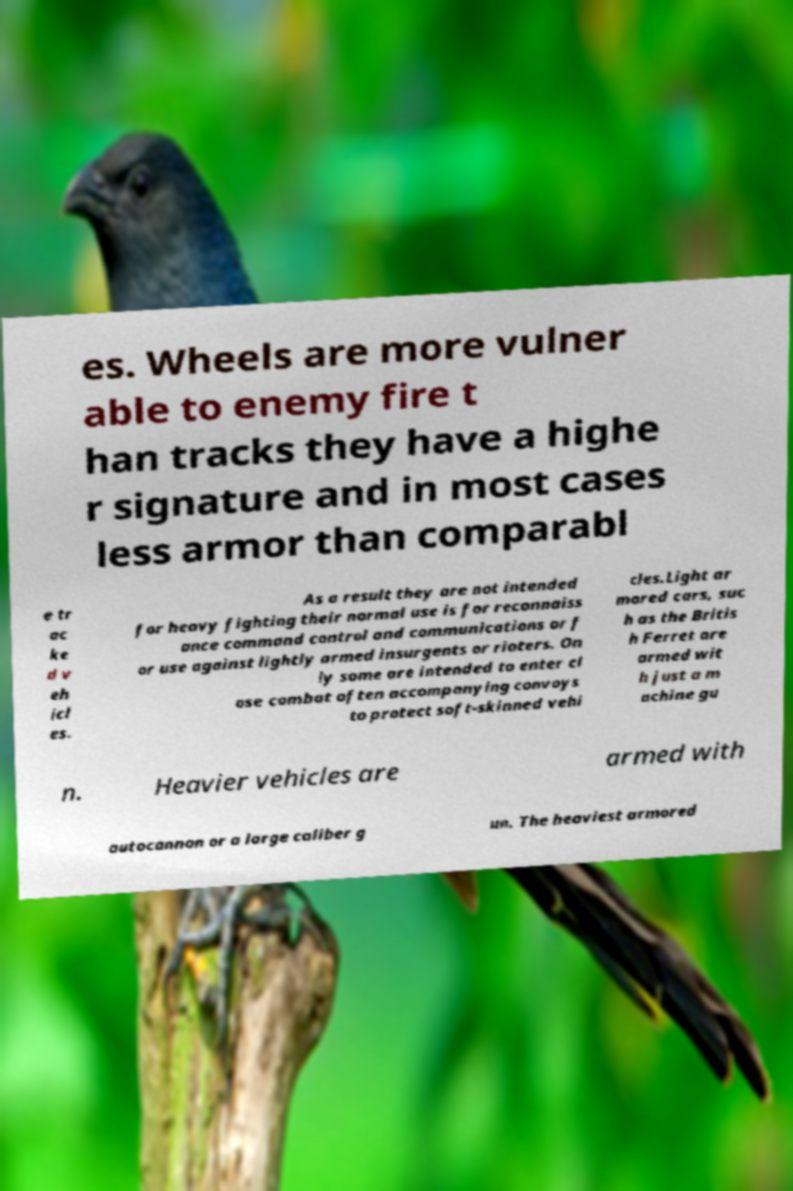For documentation purposes, I need the text within this image transcribed. Could you provide that? es. Wheels are more vulner able to enemy fire t han tracks they have a highe r signature and in most cases less armor than comparabl e tr ac ke d v eh icl es. As a result they are not intended for heavy fighting their normal use is for reconnaiss ance command control and communications or f or use against lightly armed insurgents or rioters. On ly some are intended to enter cl ose combat often accompanying convoys to protect soft-skinned vehi cles.Light ar mored cars, suc h as the Britis h Ferret are armed wit h just a m achine gu n. Heavier vehicles are armed with autocannon or a large caliber g un. The heaviest armored 